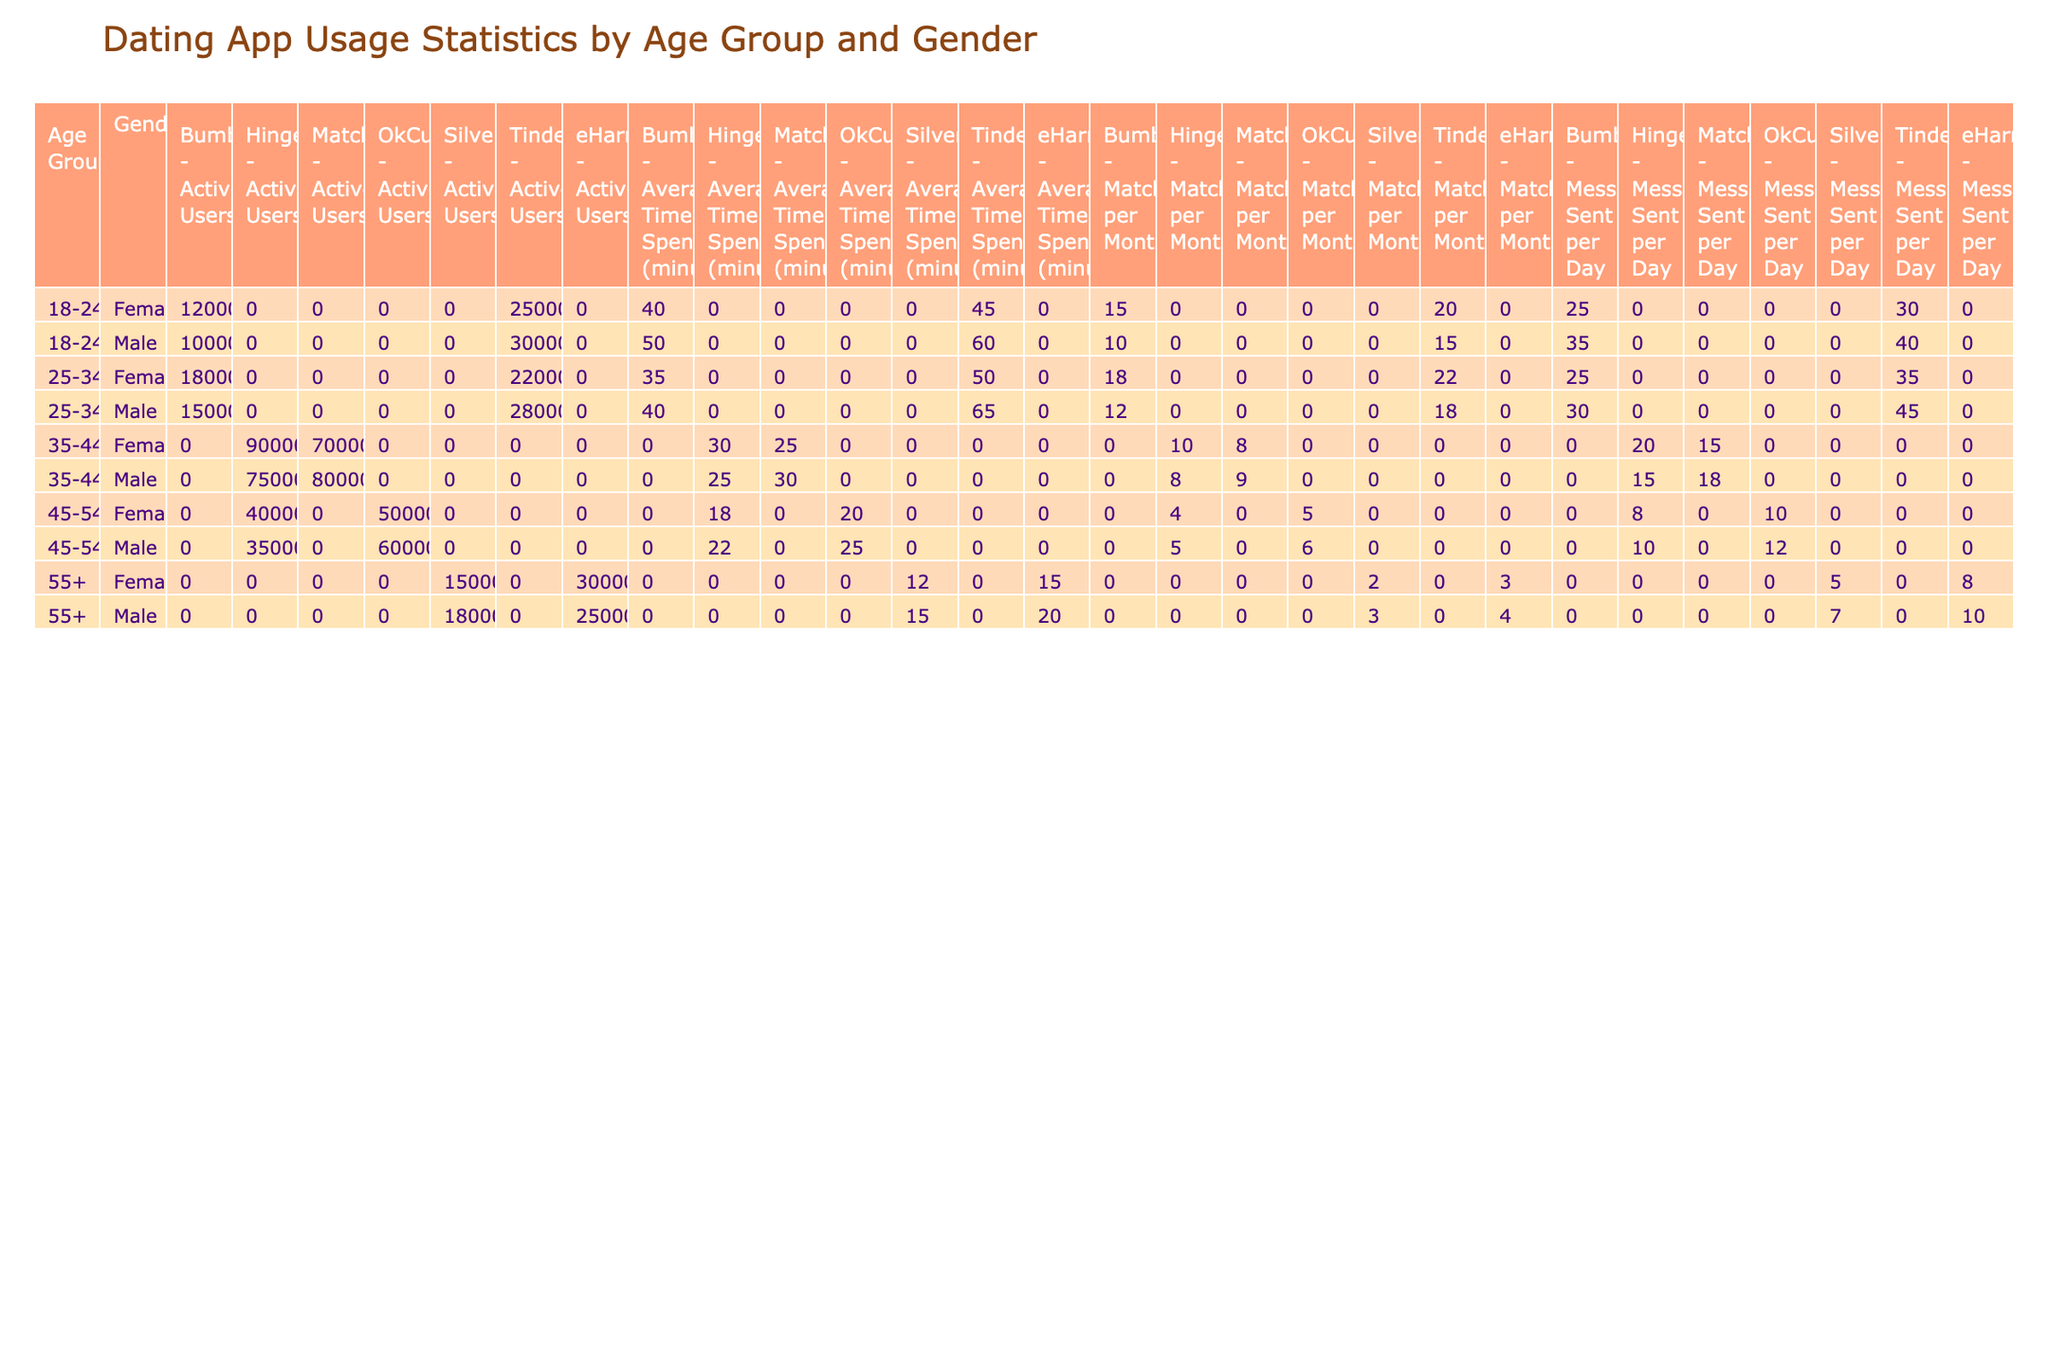What is the total number of active users for males aged 25-34 on Tinder? For males aged 25-34, we look at the "Active Users" column for the Tinder app in that age group. The total is 2,800,000.
Answer: 2800000 Which dating app has the highest average time spent per day for females aged 18-24? For females aged 18-24, we compare the "Average Time Spent" column for Tinder and Bumble. Tinder has 45 minutes and Bumble has 40 minutes, so Tinder is the highest.
Answer: Tinder Are there more messages sent per day by males aged 35-44 using Hinge or Match.com? For males aged 35-44, we check the "Messages Sent per Day" for Hinge (15) and Match.com (18). Match.com has a higher value, so the answer is Match.com.
Answer: Match.com What is the difference in the number of active users between males and females in the 45-54 age group on OkCupid? For males aged 45-54, the active users count is 600,000, and for females, it is 500,000. The difference is 600,000 - 500,000 = 100,000.
Answer: 100000 How many total matches per month do females aged 25-34 have across all apps in the table? We calculate total matches per month for females aged 25-34 by adding matches for Bumble (18), Tinder (22), and Hinge (4): 18 + 22 + 4 = 44.
Answer: 44 Do males aged 55 and over spend more time on average per day on eHarmony than females on SilverSingles? The average time for males on eHarmony is 20 minutes while females on SilverSingles spend 12 minutes. Yes, males spend more time on eHarmony.
Answer: Yes Which age group has the highest total number of active users across all apps for females? To find this, we sum the active users for females in each age group: 2,500,000 (18-24) + 1,800,000 (25-34) + 900,000 (35-44) + 500,000 (45-54) + 300,000 (55+) = 6,000,000. The 18-24 age group has the highest.
Answer: 18-24 Are there more matches per month for males on Tinder than on Bumble in the 18-24 age group? Males on Tinder have 15 matches per month while on Bumble they have 10 matches. Since 15 is greater than 10, the answer is yes.
Answer: Yes What is the average number of messages sent per day by the 18-24 age group males across all dating apps? We sum the messages sent for 18-24 age group males: Tinder (40) + Bumble (35) = 75. Then we divide by 2 (the number of apps), resulting in an average of 75/2 = 37.5.
Answer: 37.5 